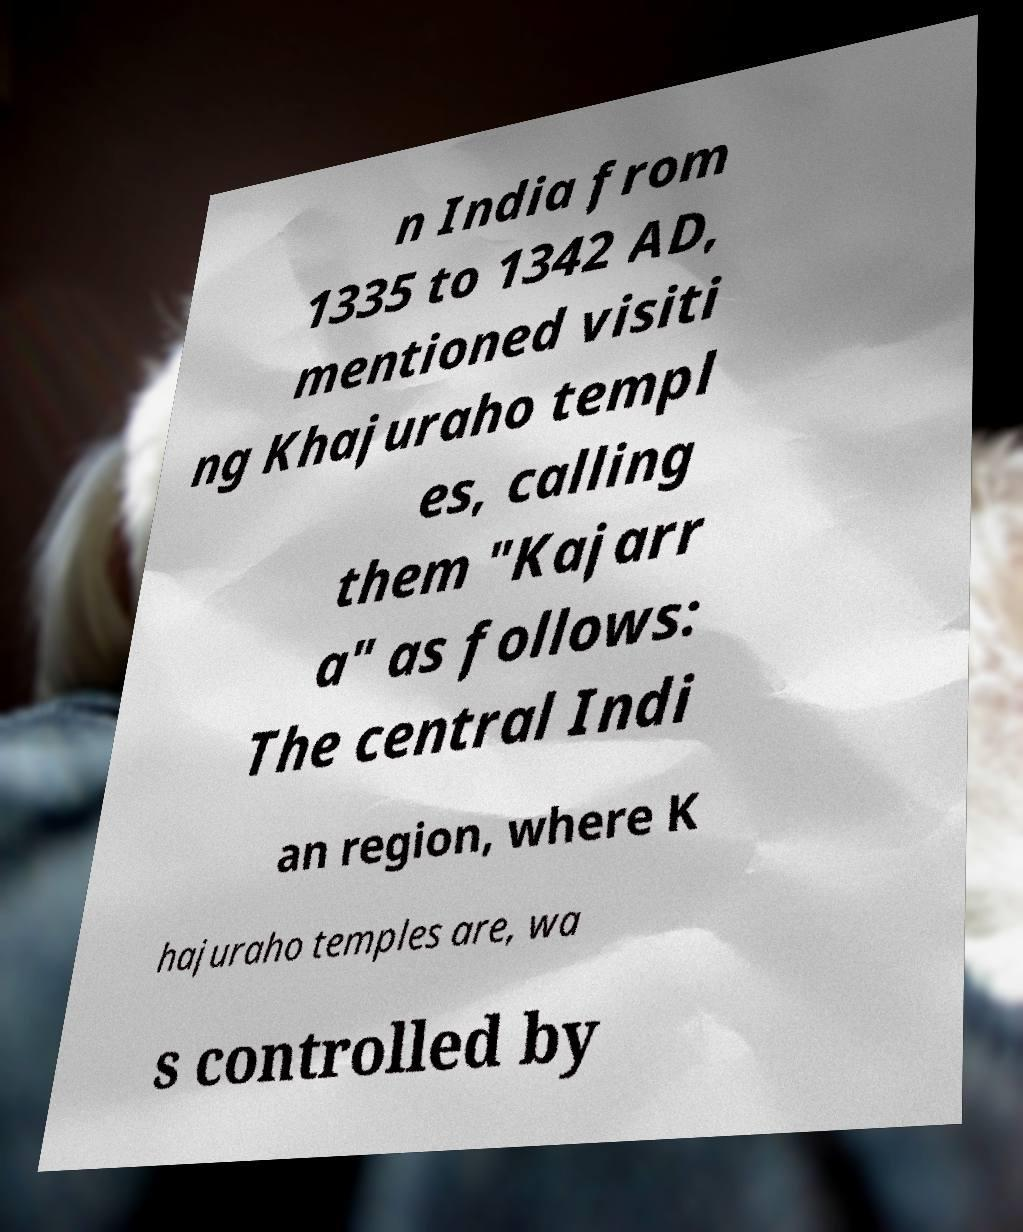Could you assist in decoding the text presented in this image and type it out clearly? n India from 1335 to 1342 AD, mentioned visiti ng Khajuraho templ es, calling them "Kajarr a" as follows: The central Indi an region, where K hajuraho temples are, wa s controlled by 